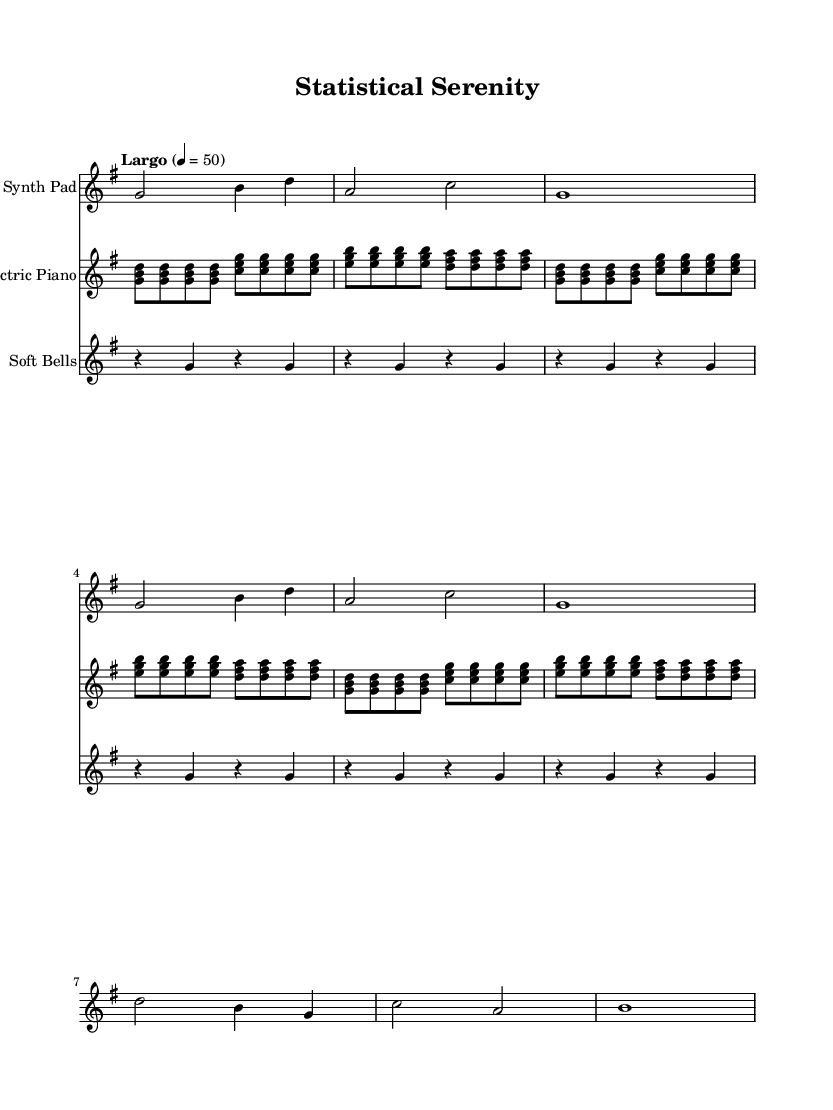What is the key signature of this music? The key signature is G major, which has one sharp (F#). This is indicated by the presence of the F# note in the melodic lines.
Answer: G major What is the time signature of this music? The time signature is 4/4, which can be visually identified in the music sheet by the fractional notation at the beginning of the score. This means there are four beats per measure and a quarter note gets one beat.
Answer: 4/4 What is the tempo marking of this score? The tempo marking is Largo, which indicates a slow pace for the music. It can be found written above the score, specifying the rate of the music.
Answer: Largo How many repetitions are there for the piano section? The piano section is marked with a repeat sign for three cycles, as indicated by the "repeat unfold 3" instruction in the score. This implies the section is played three times in succession.
Answer: 3 Which instrument plays the melody in the first part of the score? The synth pad plays the melody in the first part of the score, as indicated by the relative notation and the instrument name set at the beginning of its section.
Answer: Synth Pad What type of sound does the "Soft Bells" section contribute to the overall composition? The "Soft Bells" section adds a textural and atmospheric layer to the soundscape, creating a sense of calmness and enhancing focus during study sessions. This is inferred from its gentle rhythmic patterns and placement within the overall harmonic structure.
Answer: Ambient What is the characterized sound of the piano in this piece? The piano plays a repetitive pattern that creates a foundation of harmony, contributing to the overall soothing ambiance of the composition. The use of chord clusters enriches the texture, making it conducive to focus.
Answer: Repetitive harmony 